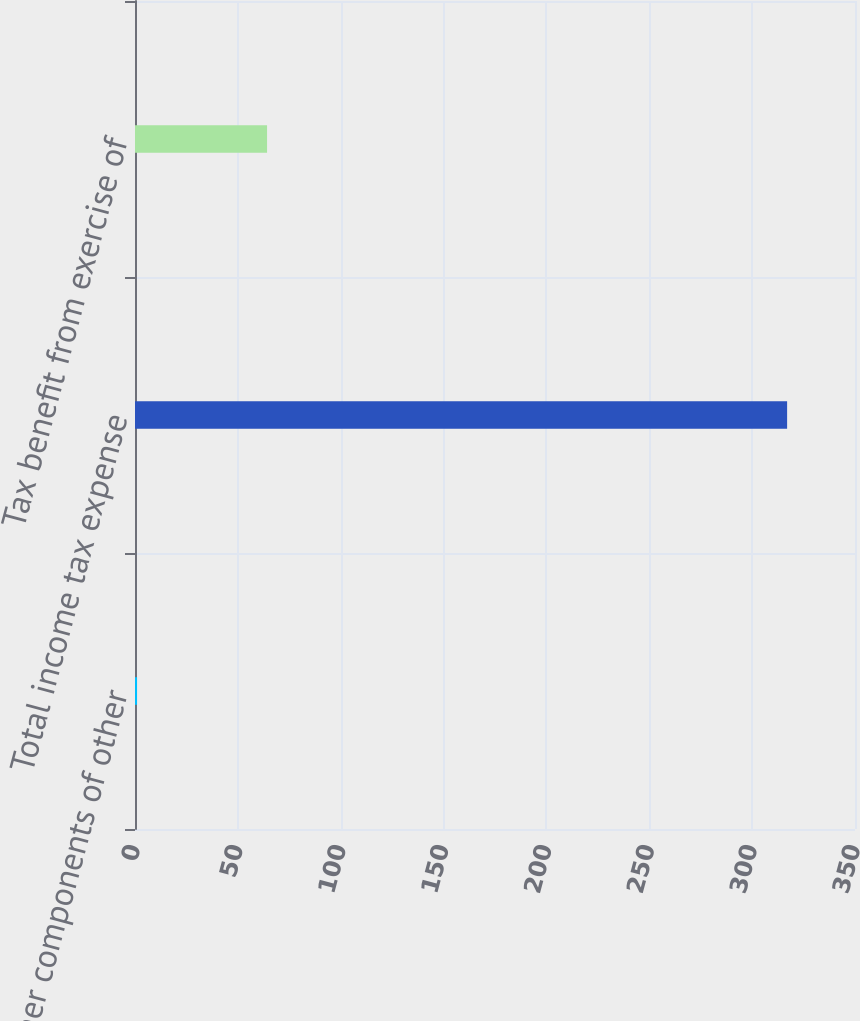<chart> <loc_0><loc_0><loc_500><loc_500><bar_chart><fcel>Other components of other<fcel>Total income tax expense<fcel>Tax benefit from exercise of<nl><fcel>1<fcel>317<fcel>64.2<nl></chart> 